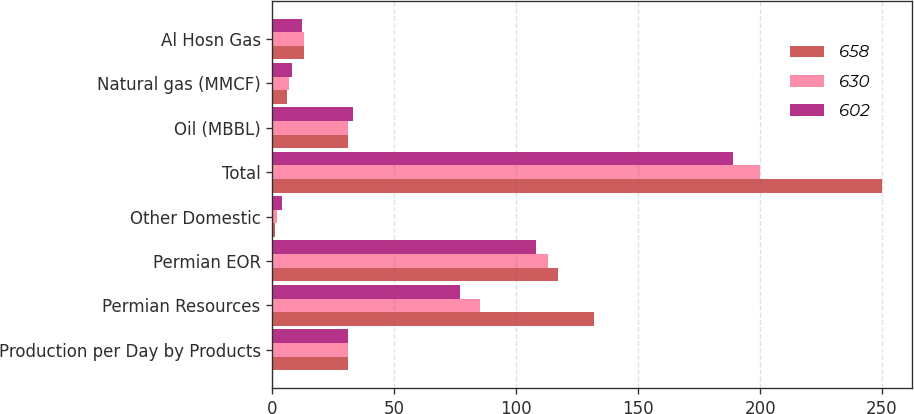Convert chart to OTSL. <chart><loc_0><loc_0><loc_500><loc_500><stacked_bar_chart><ecel><fcel>Production per Day by Products<fcel>Permian Resources<fcel>Permian EOR<fcel>Other Domestic<fcel>Total<fcel>Oil (MBBL)<fcel>Natural gas (MMCF)<fcel>Al Hosn Gas<nl><fcel>658<fcel>31<fcel>132<fcel>117<fcel>1<fcel>250<fcel>31<fcel>6<fcel>13<nl><fcel>630<fcel>31<fcel>85<fcel>113<fcel>2<fcel>200<fcel>31<fcel>7<fcel>13<nl><fcel>602<fcel>31<fcel>77<fcel>108<fcel>4<fcel>189<fcel>33<fcel>8<fcel>12<nl></chart> 